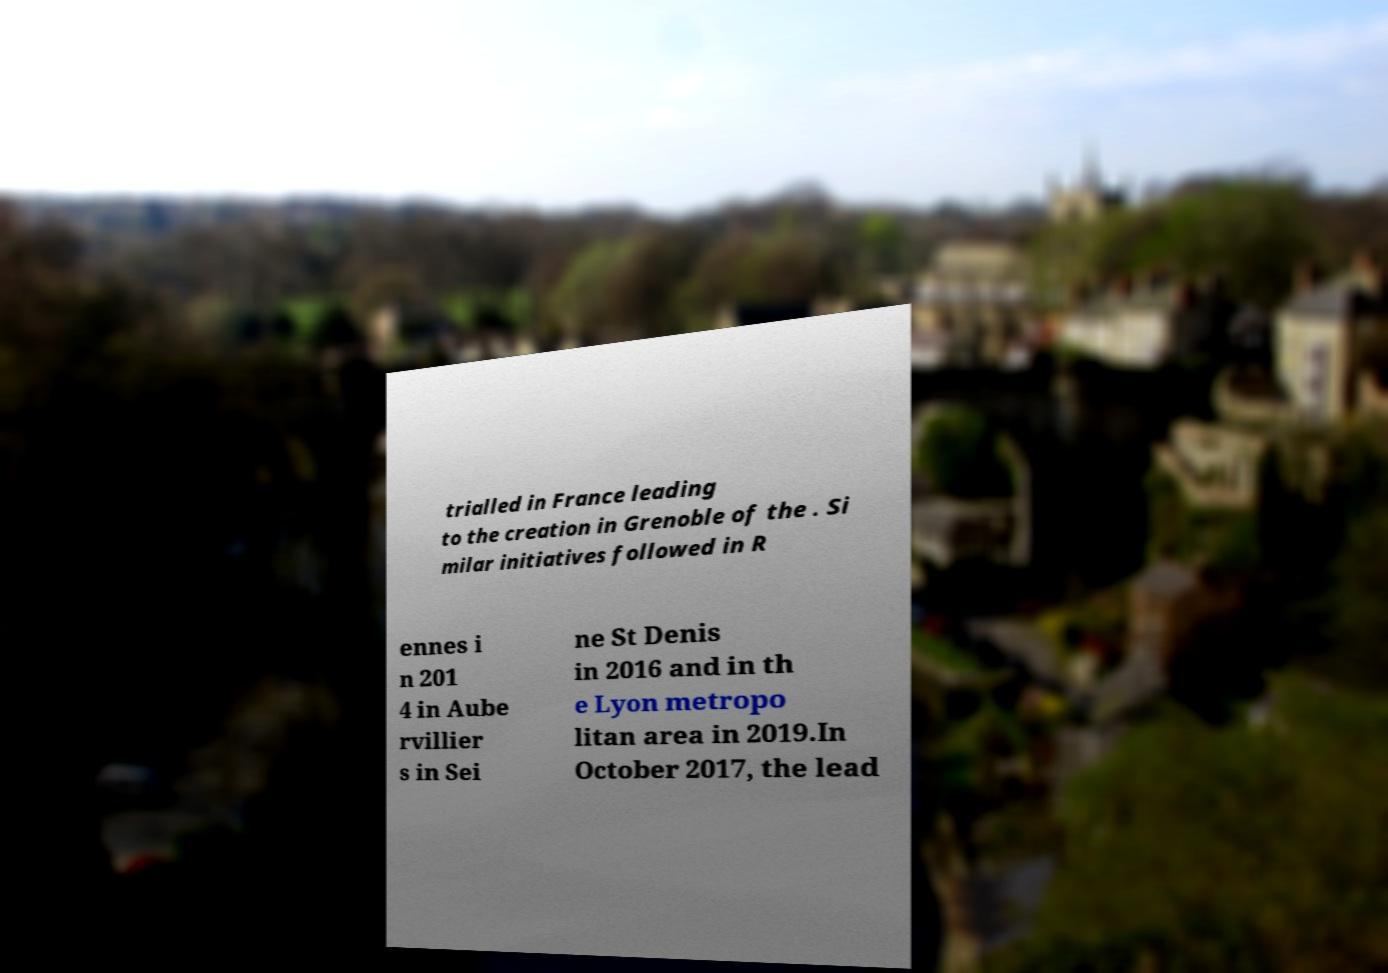I need the written content from this picture converted into text. Can you do that? trialled in France leading to the creation in Grenoble of the . Si milar initiatives followed in R ennes i n 201 4 in Aube rvillier s in Sei ne St Denis in 2016 and in th e Lyon metropo litan area in 2019.In October 2017, the lead 